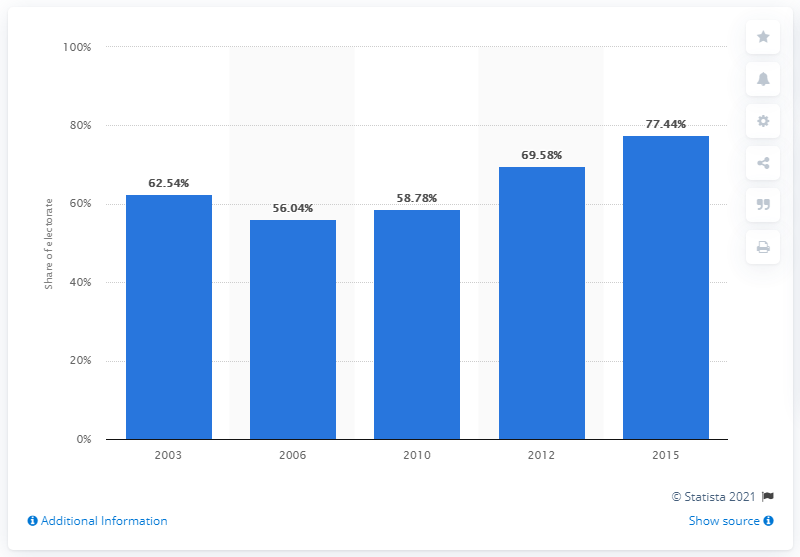List a handful of essential elements in this visual. In the 2015 elections, a total of 77.44% of the electorate participated. 